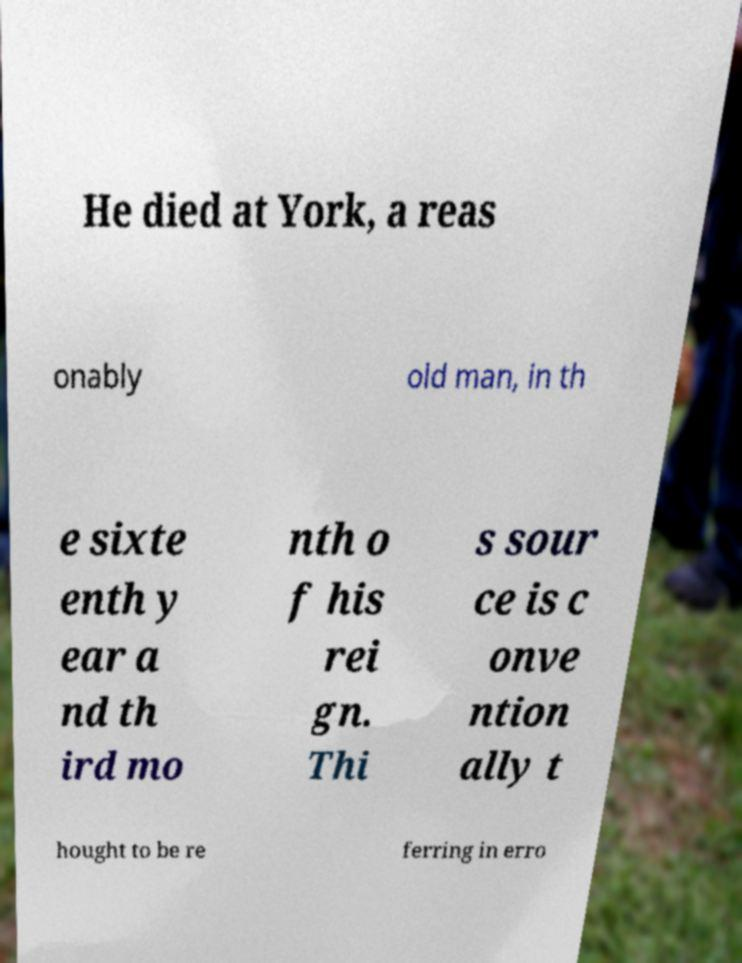Please read and relay the text visible in this image. What does it say? He died at York, a reas onably old man, in th e sixte enth y ear a nd th ird mo nth o f his rei gn. Thi s sour ce is c onve ntion ally t hought to be re ferring in erro 